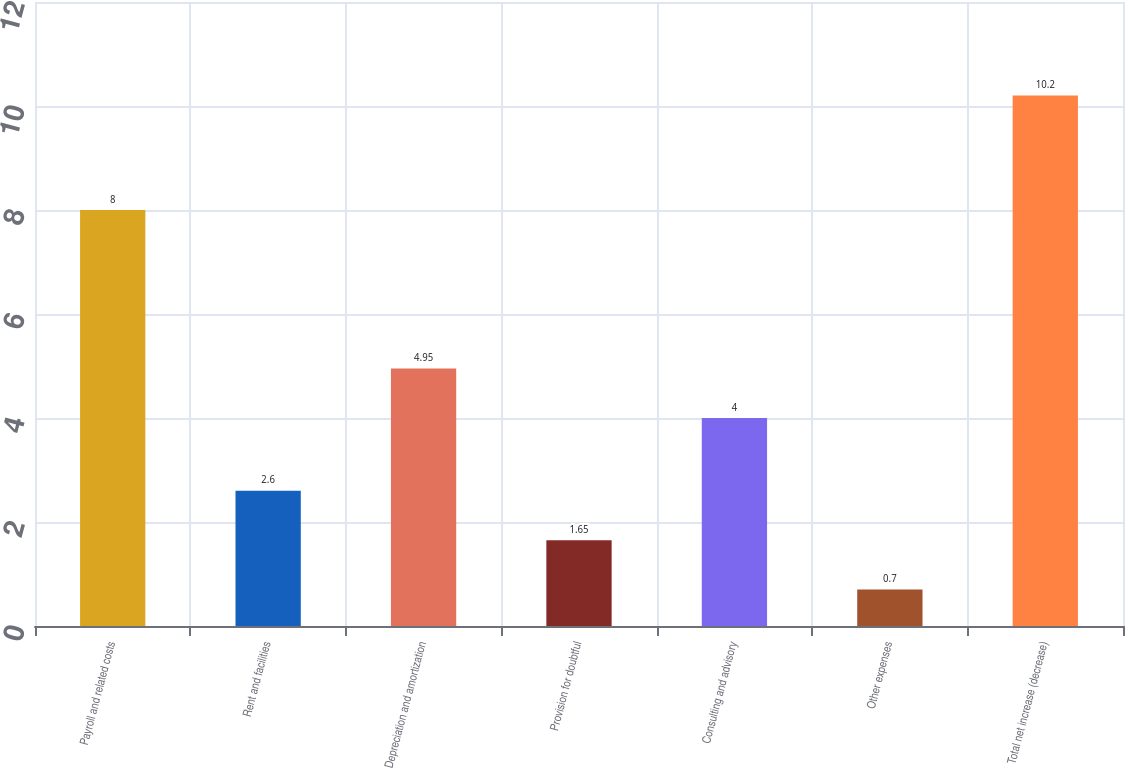<chart> <loc_0><loc_0><loc_500><loc_500><bar_chart><fcel>Payroll and related costs<fcel>Rent and facilities<fcel>Depreciation and amortization<fcel>Provision for doubtful<fcel>Consulting and advisory<fcel>Other expenses<fcel>Total net increase (decrease)<nl><fcel>8<fcel>2.6<fcel>4.95<fcel>1.65<fcel>4<fcel>0.7<fcel>10.2<nl></chart> 